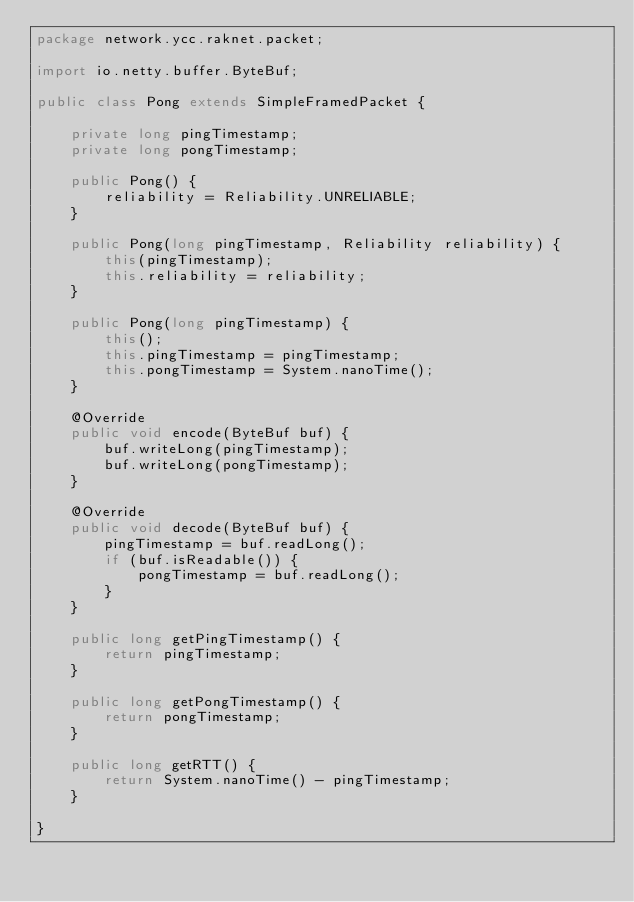<code> <loc_0><loc_0><loc_500><loc_500><_Java_>package network.ycc.raknet.packet;

import io.netty.buffer.ByteBuf;

public class Pong extends SimpleFramedPacket {

    private long pingTimestamp;
    private long pongTimestamp;

    public Pong() {
        reliability = Reliability.UNRELIABLE;
    }

    public Pong(long pingTimestamp, Reliability reliability) {
        this(pingTimestamp);
        this.reliability = reliability;
    }

    public Pong(long pingTimestamp) {
        this();
        this.pingTimestamp = pingTimestamp;
        this.pongTimestamp = System.nanoTime();
    }

    @Override
    public void encode(ByteBuf buf) {
        buf.writeLong(pingTimestamp);
        buf.writeLong(pongTimestamp);
    }

    @Override
    public void decode(ByteBuf buf) {
        pingTimestamp = buf.readLong();
        if (buf.isReadable()) {
            pongTimestamp = buf.readLong();
        }
    }

    public long getPingTimestamp() {
        return pingTimestamp;
    }

    public long getPongTimestamp() {
        return pongTimestamp;
    }

    public long getRTT() {
        return System.nanoTime() - pingTimestamp;
    }

}</code> 